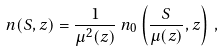Convert formula to latex. <formula><loc_0><loc_0><loc_500><loc_500>n ( S , z ) = \frac { 1 } { \mu ^ { 2 } ( z ) } \, n _ { 0 } \left ( \frac { S } { \mu ( z ) } , z \right ) \, ,</formula> 